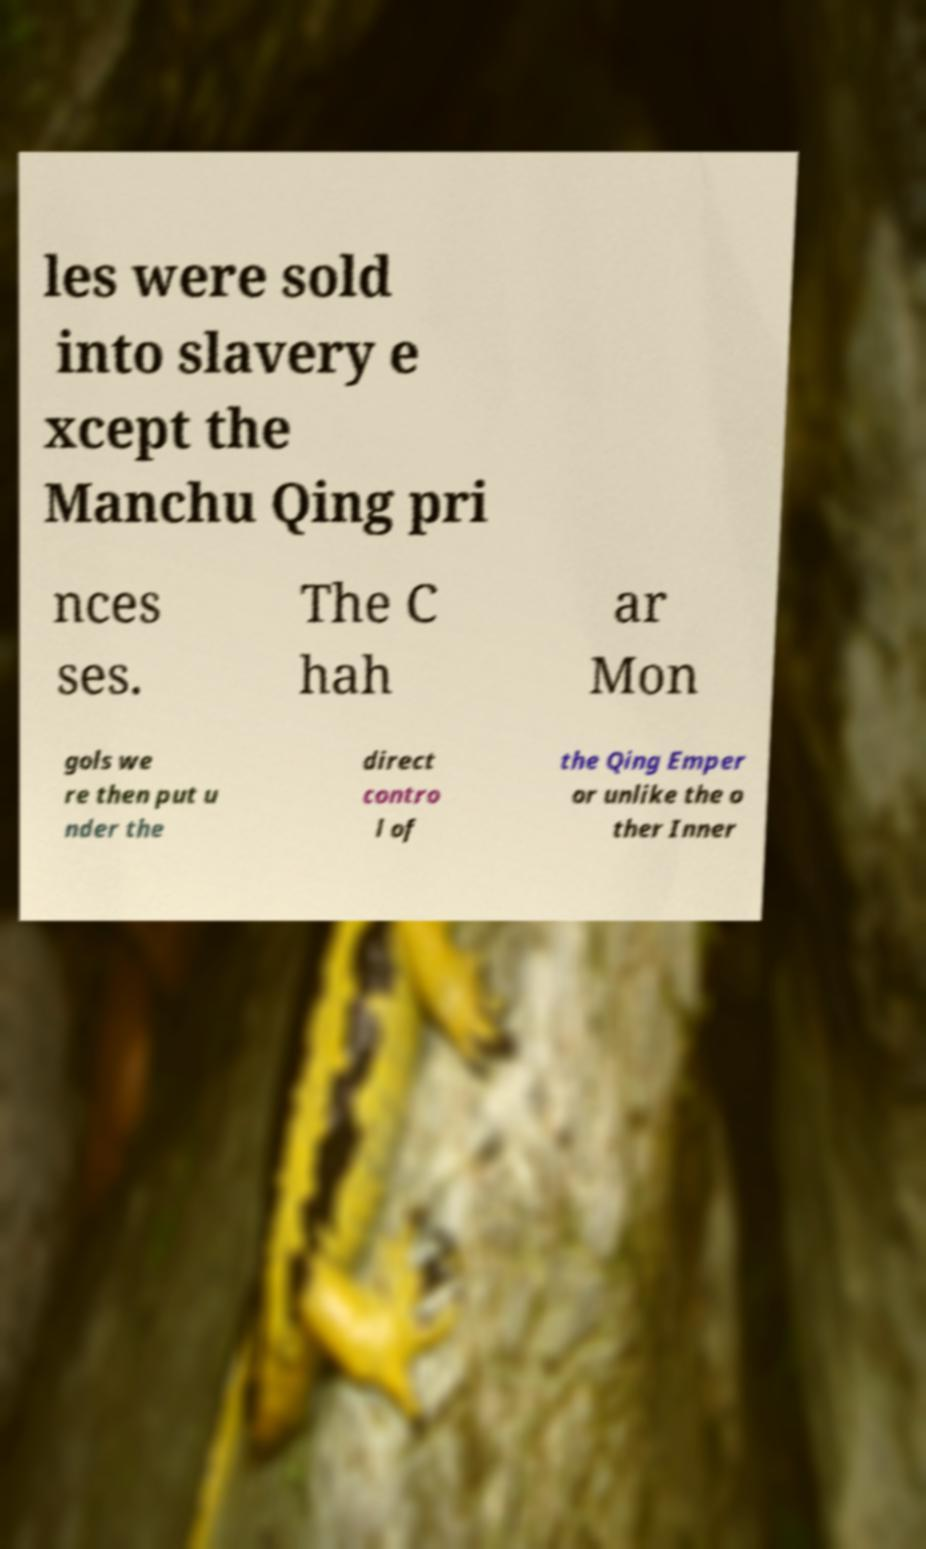For documentation purposes, I need the text within this image transcribed. Could you provide that? les were sold into slavery e xcept the Manchu Qing pri nces ses. The C hah ar Mon gols we re then put u nder the direct contro l of the Qing Emper or unlike the o ther Inner 